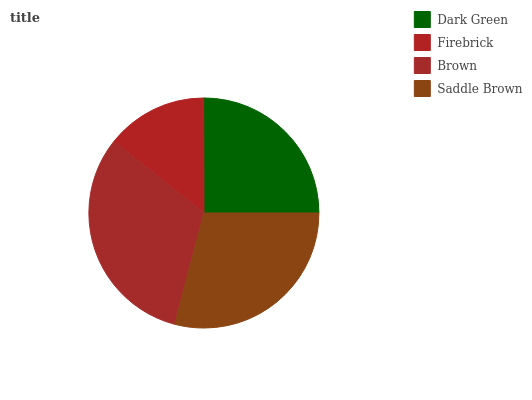Is Firebrick the minimum?
Answer yes or no. Yes. Is Brown the maximum?
Answer yes or no. Yes. Is Brown the minimum?
Answer yes or no. No. Is Firebrick the maximum?
Answer yes or no. No. Is Brown greater than Firebrick?
Answer yes or no. Yes. Is Firebrick less than Brown?
Answer yes or no. Yes. Is Firebrick greater than Brown?
Answer yes or no. No. Is Brown less than Firebrick?
Answer yes or no. No. Is Saddle Brown the high median?
Answer yes or no. Yes. Is Dark Green the low median?
Answer yes or no. Yes. Is Dark Green the high median?
Answer yes or no. No. Is Firebrick the low median?
Answer yes or no. No. 